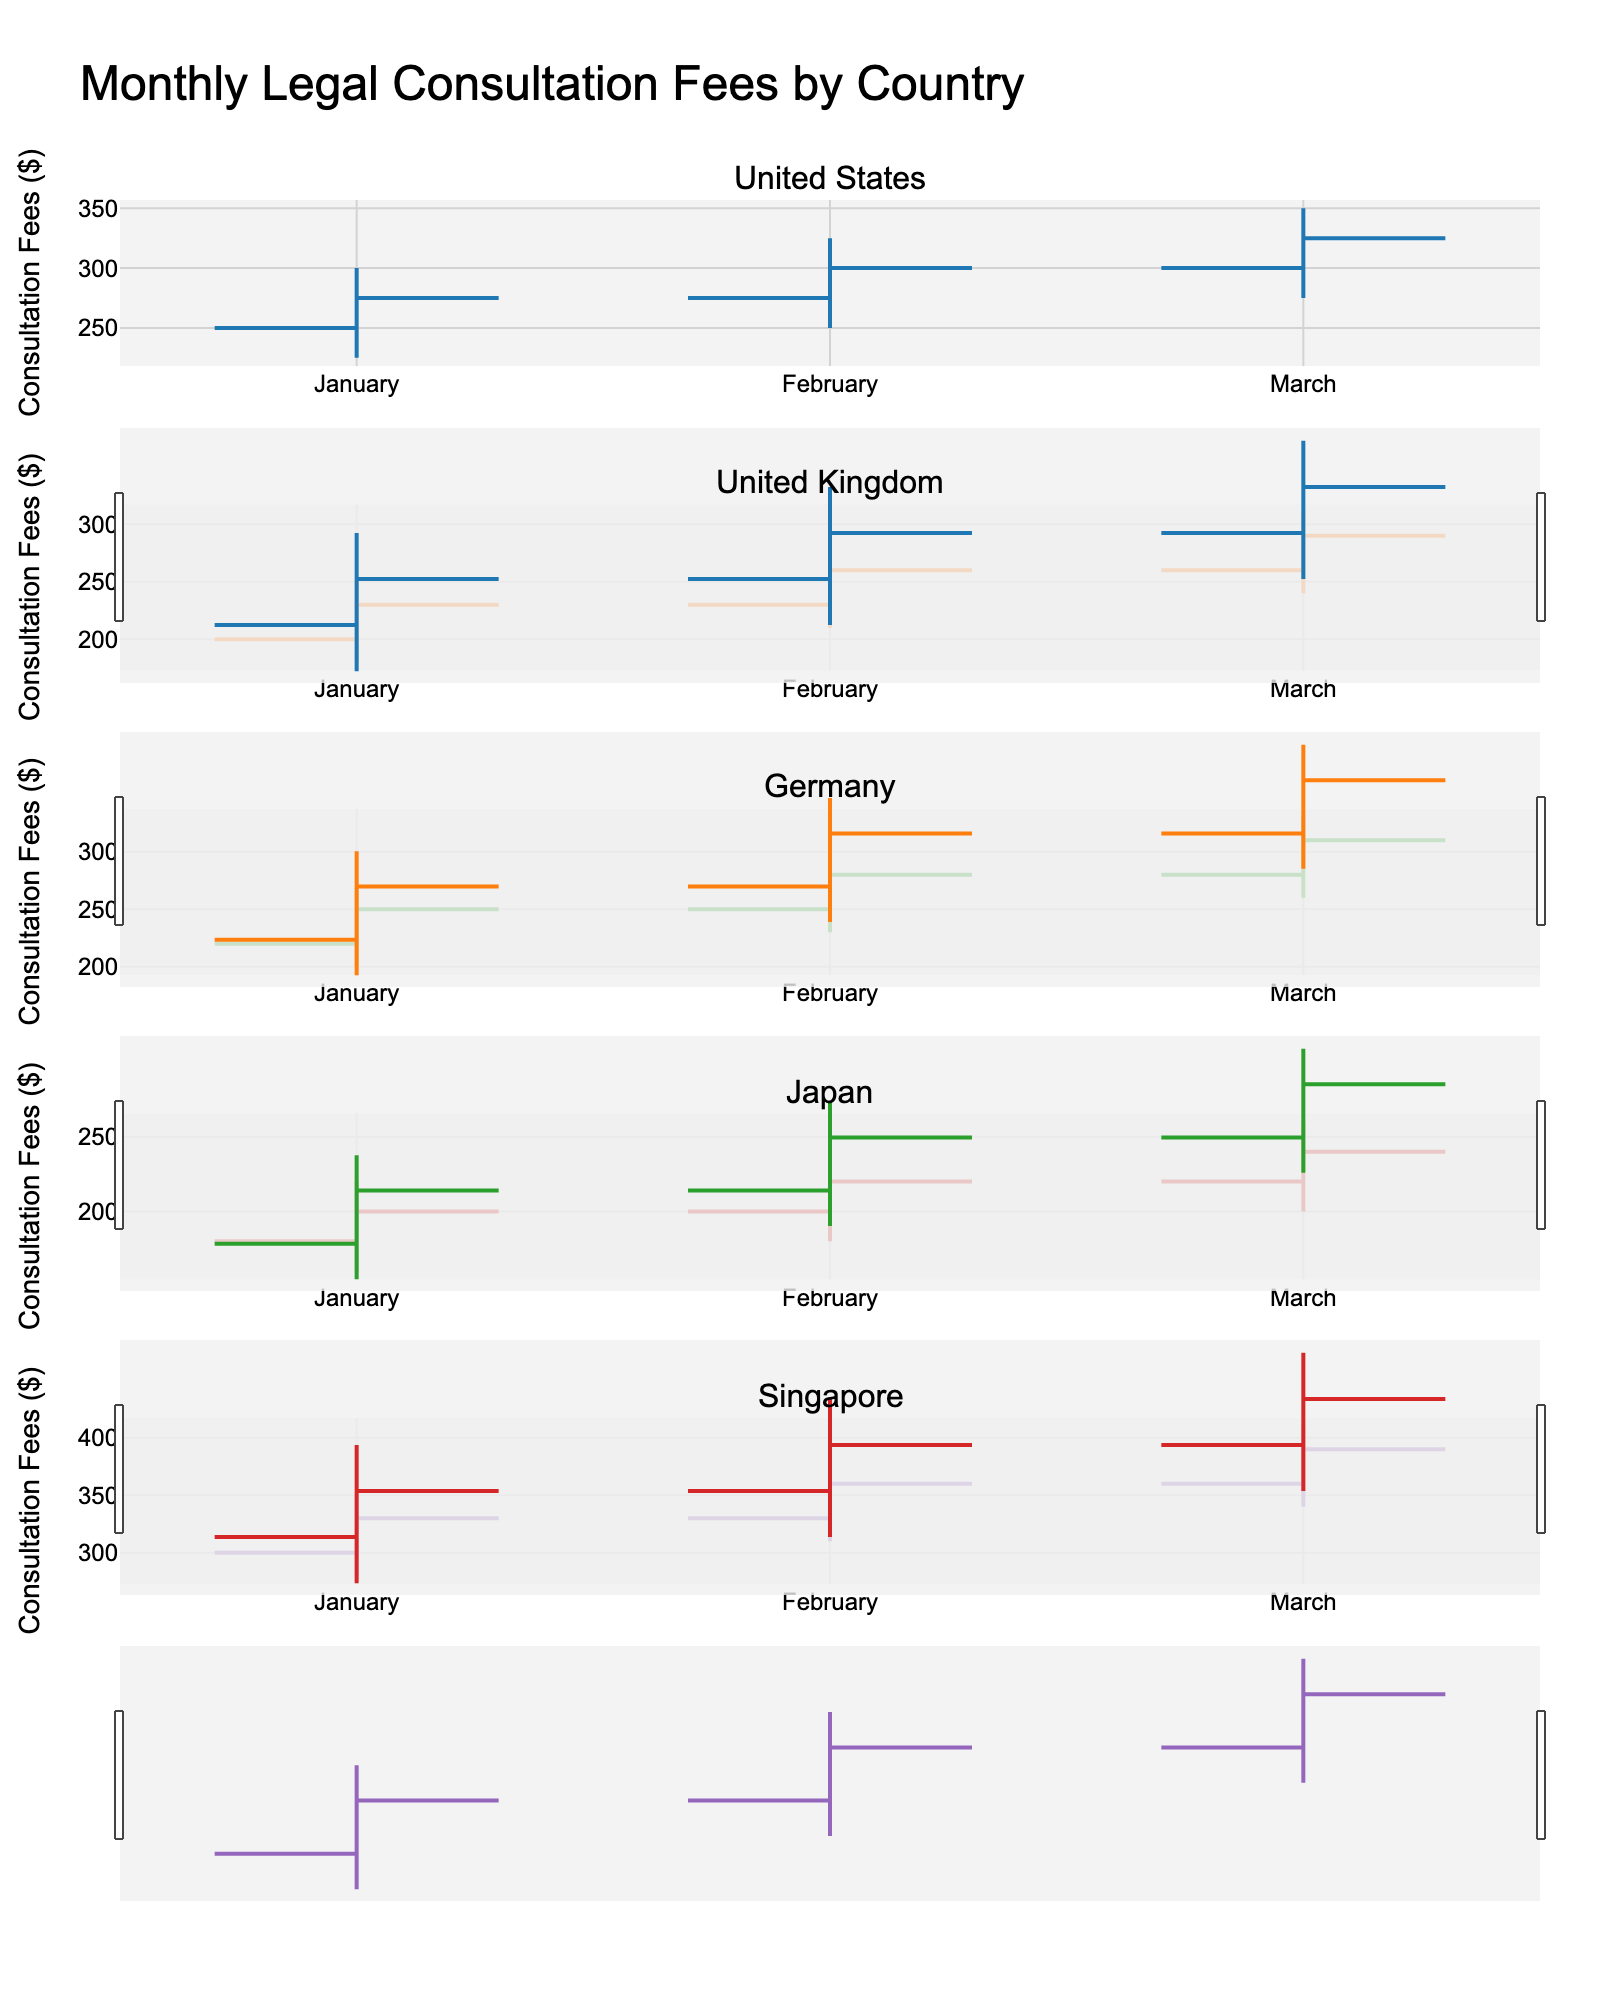What is the title of the figure? The title is usually located at the top of the figure. In this case, it reads: 'Monthly Legal Consultation Fees by Country'.
Answer: Monthly Legal Consultation Fees by Country Which country has the highest closing consultation fee in March? For each subplot corresponding to different countries' March data, compare the closing fees. The highest closing fee in March is $390 for Singapore.
Answer: Singapore What is the average closing fee in the United Kingdom across the three months? Sum the closing fees for the United Kingdom (January: $230, February: $260, March: $290) and divide by 3. The average is ($230 + $260 + $290)/3 = $780/3 = $260.
Answer: $260 Which country shows the smallest increase from Open to Close fees in January? In January, check the Open and Close fees: United States ($250 -> $275), United Kingdom ($200 -> $230), Germany ($220 -> $250), Japan ($180 -> $200), Singapore ($300 -> $330). The smallest increase is $20 for Japan ($200 - $180).
Answer: Japan How does the highest high in February compare between the United States and Singapore? For February, the high value in the United States is $325, whereas in Singapore, it is $380. Compare these values to see Singapore is $55 greater ($380 - $325).
Answer: Singapore is $55 greater What is the range of fees (High - Low) for Germany in March? For March in Germany, the high value is $330, and the low value is $260. The range is $330 - $260 = $70.
Answer: $70 In which month does Japan have the lowest low value and what is it? Examine the low values for Japan across the months (January: $160, February: $180, March: $200). The lowest low value is $160 in January.
Answer: January, $160 Which country shows the most consistent closings over the three months? Assess the small variance in closing fees: United States (275, 300, 325), United Kingdom (230, 260, 290), Germany (250, 280, 310), Japan (200, 220, 240), Singapore (330, 360, 390). The United States shows the most consistent closings with a difference of $50 ($325 - $275).
Answer: United States What trend can you observe in Singapore's closing fees over the three months? For Singapore, the closing fees increase each month: January ($330), February ($360), March ($390). The trend is a steady increase.
Answer: Steady increase Which country has the highest opening fee in February and what is it? Analyze the opening fees in February: United States ($275), United Kingdom ($230), Germany ($250), Japan ($200), Singapore ($330). The highest opening fee is $330 for Singapore.
Answer: Singapore, $330 